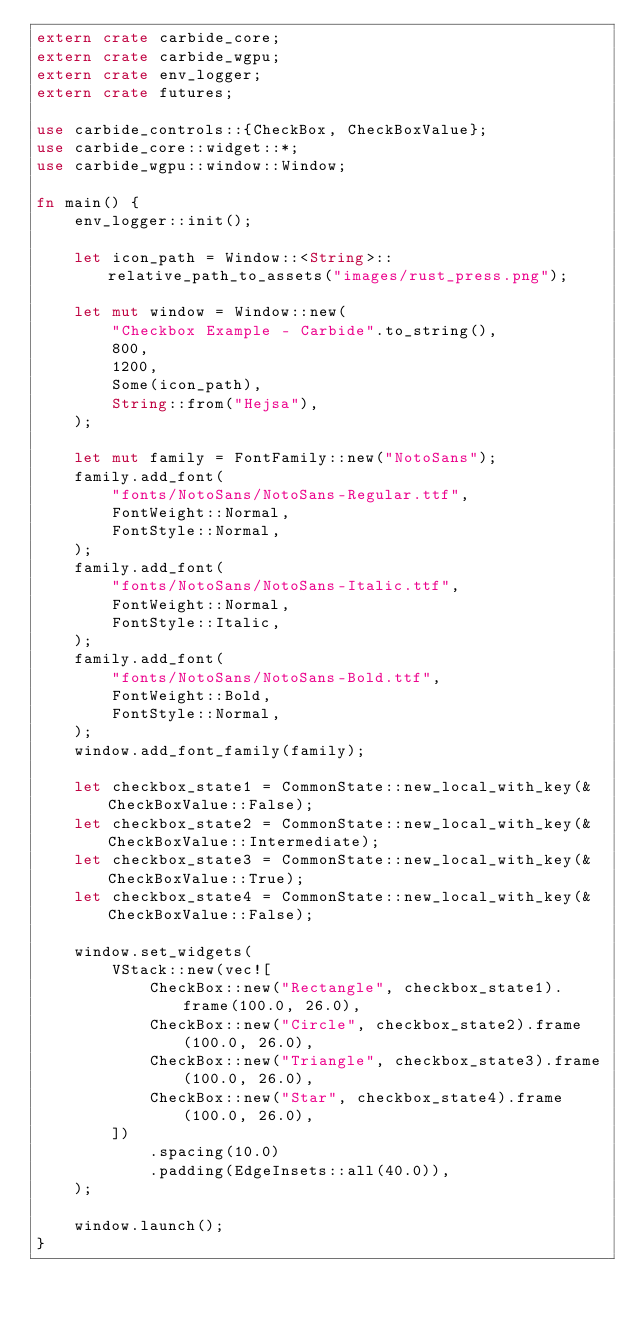<code> <loc_0><loc_0><loc_500><loc_500><_Rust_>extern crate carbide_core;
extern crate carbide_wgpu;
extern crate env_logger;
extern crate futures;

use carbide_controls::{CheckBox, CheckBoxValue};
use carbide_core::widget::*;
use carbide_wgpu::window::Window;

fn main() {
    env_logger::init();

    let icon_path = Window::<String>::relative_path_to_assets("images/rust_press.png");

    let mut window = Window::new(
        "Checkbox Example - Carbide".to_string(),
        800,
        1200,
        Some(icon_path),
        String::from("Hejsa"),
    );

    let mut family = FontFamily::new("NotoSans");
    family.add_font(
        "fonts/NotoSans/NotoSans-Regular.ttf",
        FontWeight::Normal,
        FontStyle::Normal,
    );
    family.add_font(
        "fonts/NotoSans/NotoSans-Italic.ttf",
        FontWeight::Normal,
        FontStyle::Italic,
    );
    family.add_font(
        "fonts/NotoSans/NotoSans-Bold.ttf",
        FontWeight::Bold,
        FontStyle::Normal,
    );
    window.add_font_family(family);

    let checkbox_state1 = CommonState::new_local_with_key(&CheckBoxValue::False);
    let checkbox_state2 = CommonState::new_local_with_key(&CheckBoxValue::Intermediate);
    let checkbox_state3 = CommonState::new_local_with_key(&CheckBoxValue::True);
    let checkbox_state4 = CommonState::new_local_with_key(&CheckBoxValue::False);

    window.set_widgets(
        VStack::new(vec![
            CheckBox::new("Rectangle", checkbox_state1).frame(100.0, 26.0),
            CheckBox::new("Circle", checkbox_state2).frame(100.0, 26.0),
            CheckBox::new("Triangle", checkbox_state3).frame(100.0, 26.0),
            CheckBox::new("Star", checkbox_state4).frame(100.0, 26.0),
        ])
            .spacing(10.0)
            .padding(EdgeInsets::all(40.0)),
    );

    window.launch();
}
</code> 